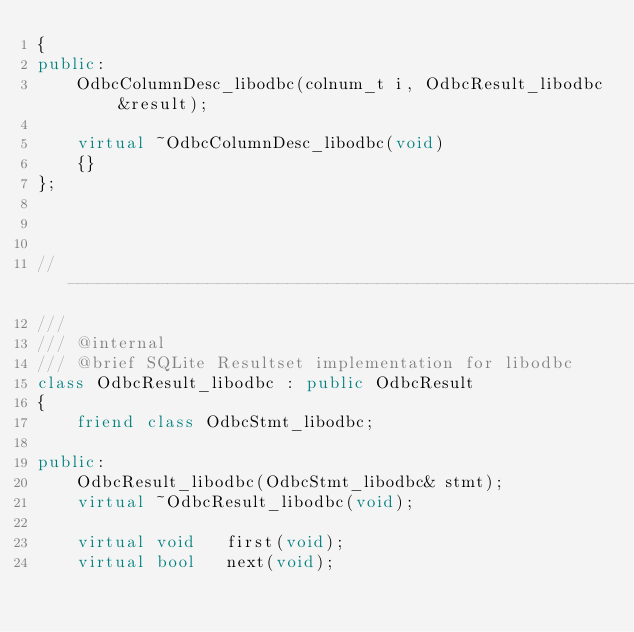<code> <loc_0><loc_0><loc_500><loc_500><_C++_>{
public:
    OdbcColumnDesc_libodbc(colnum_t i, OdbcResult_libodbc &result);

    virtual ~OdbcColumnDesc_libodbc(void)
    {}
};



//------------------------------------------------------------------------------
///
/// @internal
/// @brief SQLite Resultset implementation for libodbc
class OdbcResult_libodbc : public OdbcResult
{
    friend class OdbcStmt_libodbc;

public:
    OdbcResult_libodbc(OdbcStmt_libodbc& stmt);
    virtual ~OdbcResult_libodbc(void);

    virtual void   first(void);
    virtual bool   next(void);</code> 